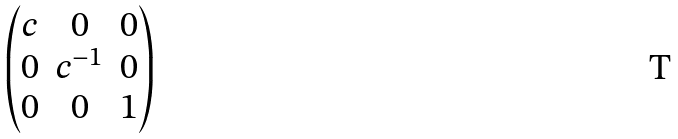<formula> <loc_0><loc_0><loc_500><loc_500>\begin{pmatrix} c & 0 & 0 \\ 0 & c ^ { - 1 } & 0 \\ 0 & 0 & 1 \end{pmatrix}</formula> 